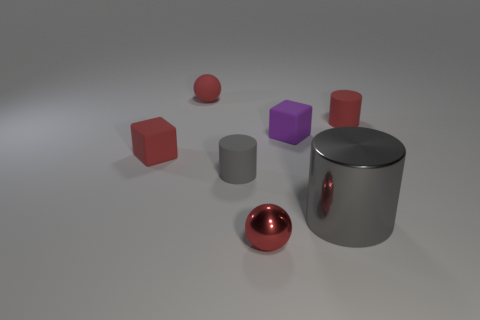Subtract all small red matte cylinders. How many cylinders are left? 2 Subtract 2 cylinders. How many cylinders are left? 1 Add 1 red rubber cubes. How many objects exist? 8 Subtract all gray cylinders. How many cylinders are left? 1 Subtract 0 yellow blocks. How many objects are left? 7 Subtract all spheres. How many objects are left? 5 Subtract all red cylinders. Subtract all purple spheres. How many cylinders are left? 2 Subtract all gray blocks. How many blue spheres are left? 0 Subtract all purple matte cylinders. Subtract all red rubber objects. How many objects are left? 4 Add 5 small red cylinders. How many small red cylinders are left? 6 